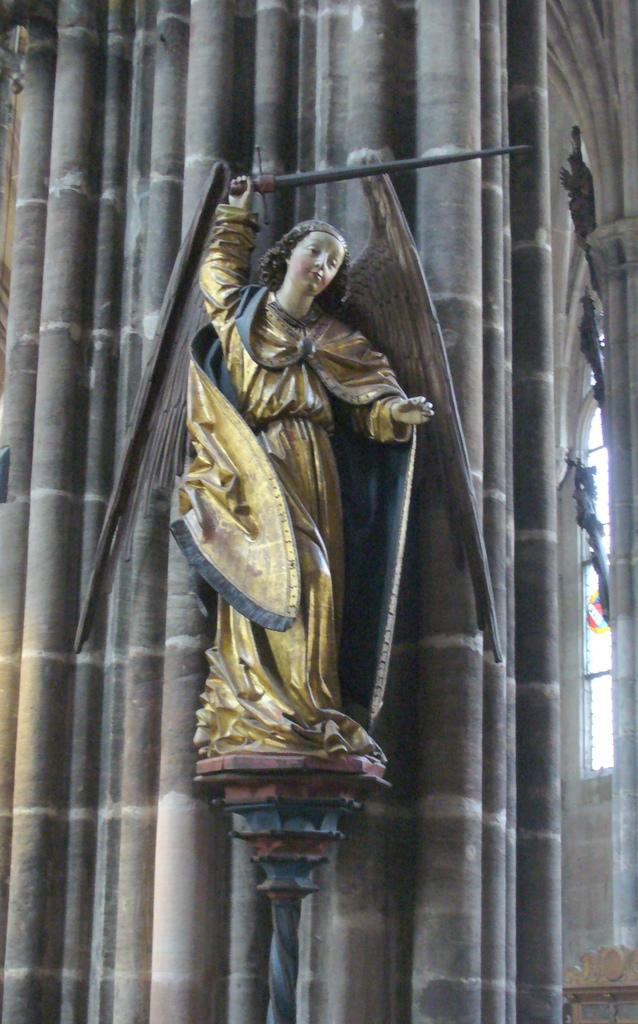What is the main subject in the center of the image? There is a statue in the center of the image. What can be seen in the background of the image? There is a building in the background of the image. How many facts can be seen with the statue's eyes in the image? The statue does not have eyes, and therefore no facts can be seen with them. 